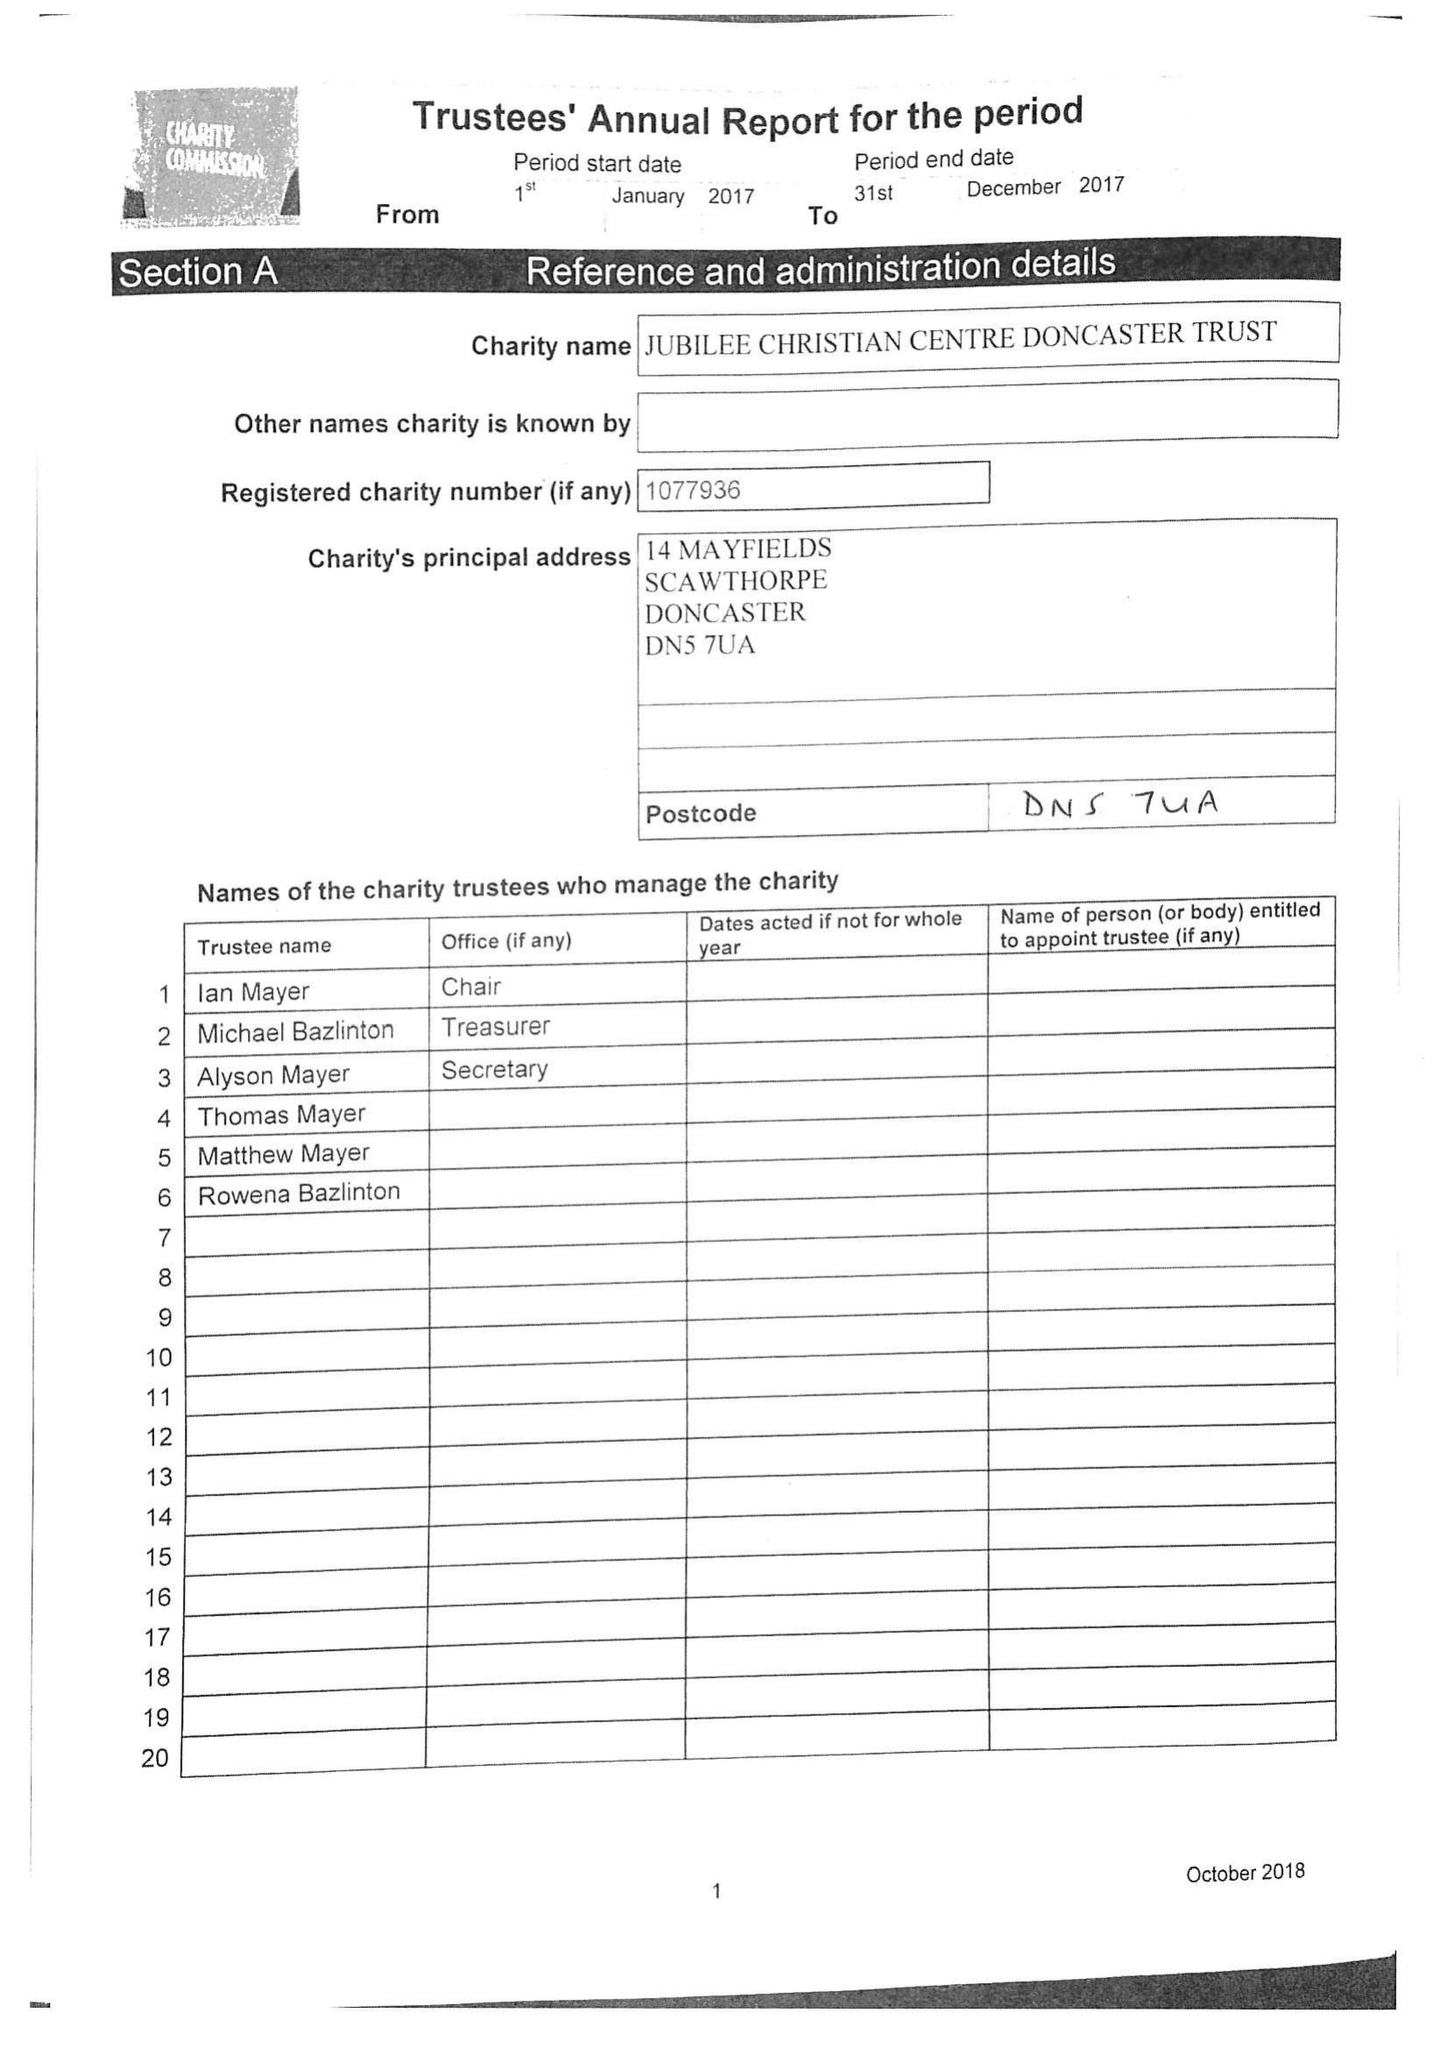What is the value for the address__post_town?
Answer the question using a single word or phrase. DONCASTER 